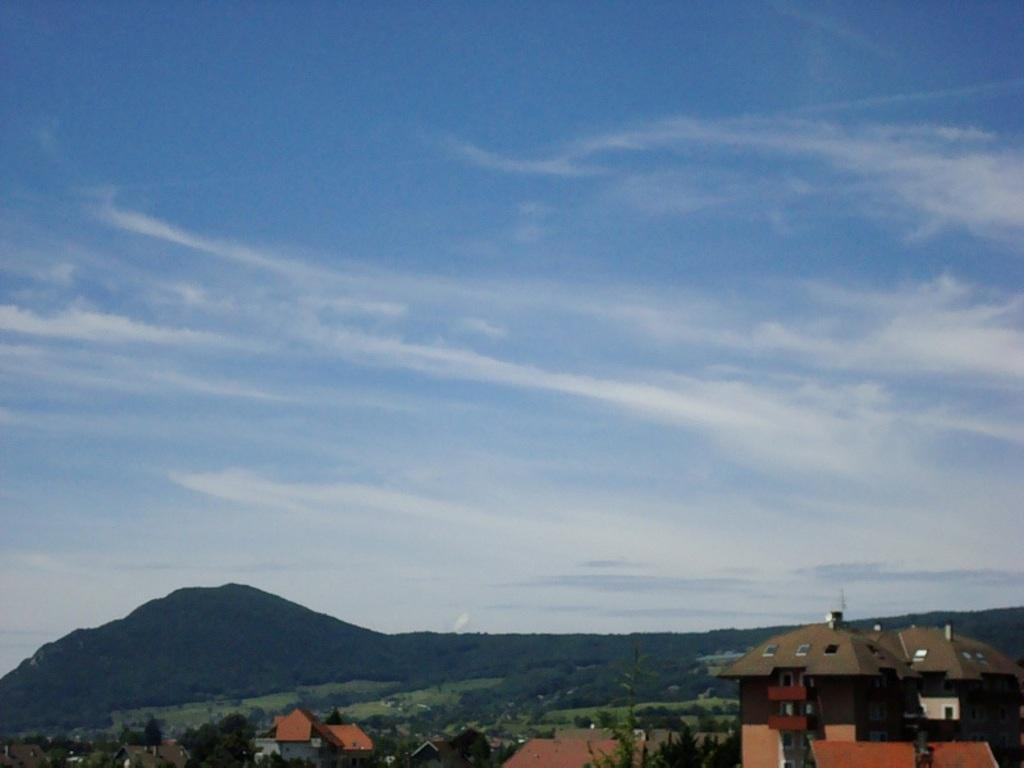What type of structures can be seen in the image? There are buildings in the image. What other natural elements are present in the image? There are trees and a hill in the image. What can be seen in the background of the image? The sky is visible in the background of the image. Is the grandfather sitting on the hill in the image? There is no mention of a grandfather or any person in the image, so we cannot determine if a grandfather is present or sitting on the hill. 